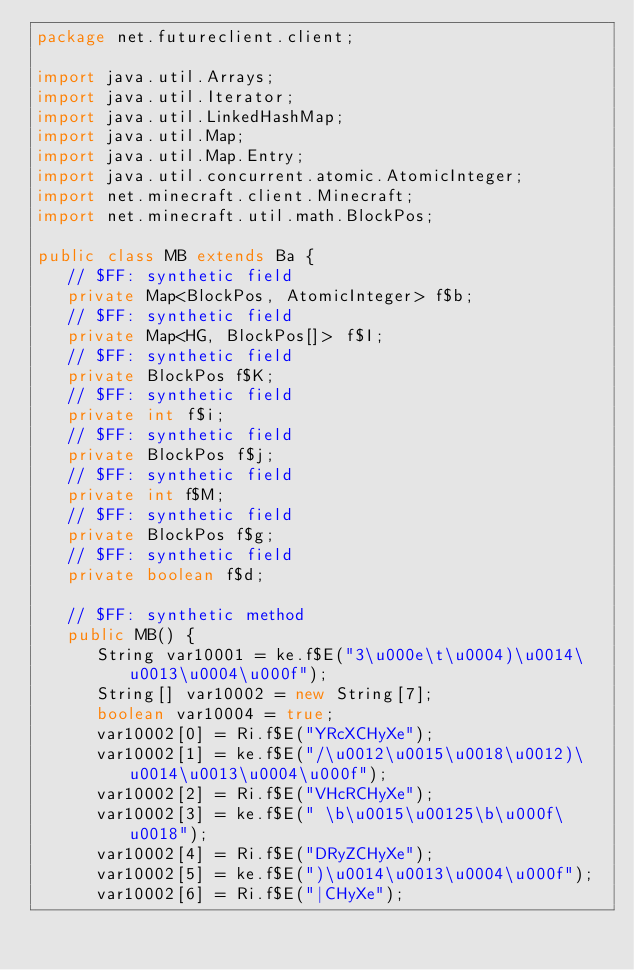<code> <loc_0><loc_0><loc_500><loc_500><_Java_>package net.futureclient.client;

import java.util.Arrays;
import java.util.Iterator;
import java.util.LinkedHashMap;
import java.util.Map;
import java.util.Map.Entry;
import java.util.concurrent.atomic.AtomicInteger;
import net.minecraft.client.Minecraft;
import net.minecraft.util.math.BlockPos;

public class MB extends Ba {
   // $FF: synthetic field
   private Map<BlockPos, AtomicInteger> f$b;
   // $FF: synthetic field
   private Map<HG, BlockPos[]> f$I;
   // $FF: synthetic field
   private BlockPos f$K;
   // $FF: synthetic field
   private int f$i;
   // $FF: synthetic field
   private BlockPos f$j;
   // $FF: synthetic field
   private int f$M;
   // $FF: synthetic field
   private BlockPos f$g;
   // $FF: synthetic field
   private boolean f$d;

   // $FF: synthetic method
   public MB() {
      String var10001 = ke.f$E("3\u000e\t\u0004)\u0014\u0013\u0004\u000f");
      String[] var10002 = new String[7];
      boolean var10004 = true;
      var10002[0] = Ri.f$E("YRcXCHyXe");
      var10002[1] = ke.f$E("/\u0012\u0015\u0018\u0012)\u0014\u0013\u0004\u000f");
      var10002[2] = Ri.f$E("VHcRCHyXe");
      var10002[3] = ke.f$E(" \b\u0015\u00125\b\u000f\u0018");
      var10002[4] = Ri.f$E("DRyZCHyXe");
      var10002[5] = ke.f$E(")\u0014\u0013\u0004\u000f");
      var10002[6] = Ri.f$E("|CHyXe");</code> 